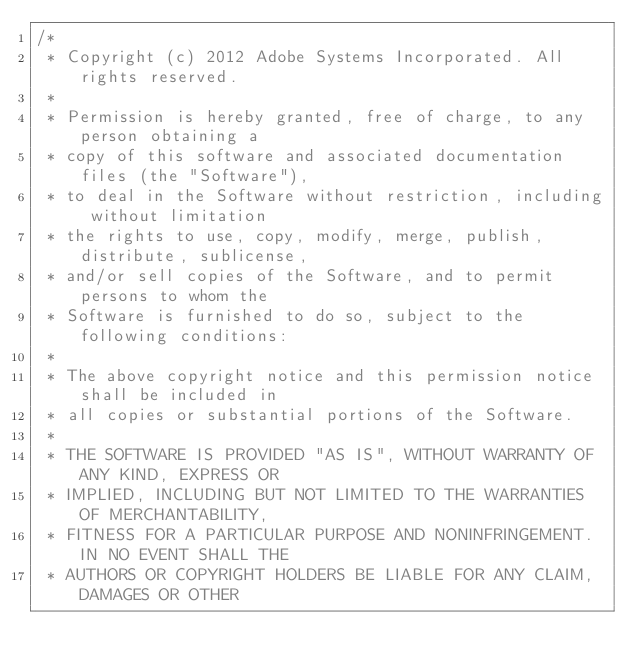<code> <loc_0><loc_0><loc_500><loc_500><_JavaScript_>/*
 * Copyright (c) 2012 Adobe Systems Incorporated. All rights reserved.
 *
 * Permission is hereby granted, free of charge, to any person obtaining a
 * copy of this software and associated documentation files (the "Software"),
 * to deal in the Software without restriction, including without limitation
 * the rights to use, copy, modify, merge, publish, distribute, sublicense,
 * and/or sell copies of the Software, and to permit persons to whom the
 * Software is furnished to do so, subject to the following conditions:
 *
 * The above copyright notice and this permission notice shall be included in
 * all copies or substantial portions of the Software.
 *
 * THE SOFTWARE IS PROVIDED "AS IS", WITHOUT WARRANTY OF ANY KIND, EXPRESS OR
 * IMPLIED, INCLUDING BUT NOT LIMITED TO THE WARRANTIES OF MERCHANTABILITY,
 * FITNESS FOR A PARTICULAR PURPOSE AND NONINFRINGEMENT. IN NO EVENT SHALL THE
 * AUTHORS OR COPYRIGHT HOLDERS BE LIABLE FOR ANY CLAIM, DAMAGES OR OTHER</code> 